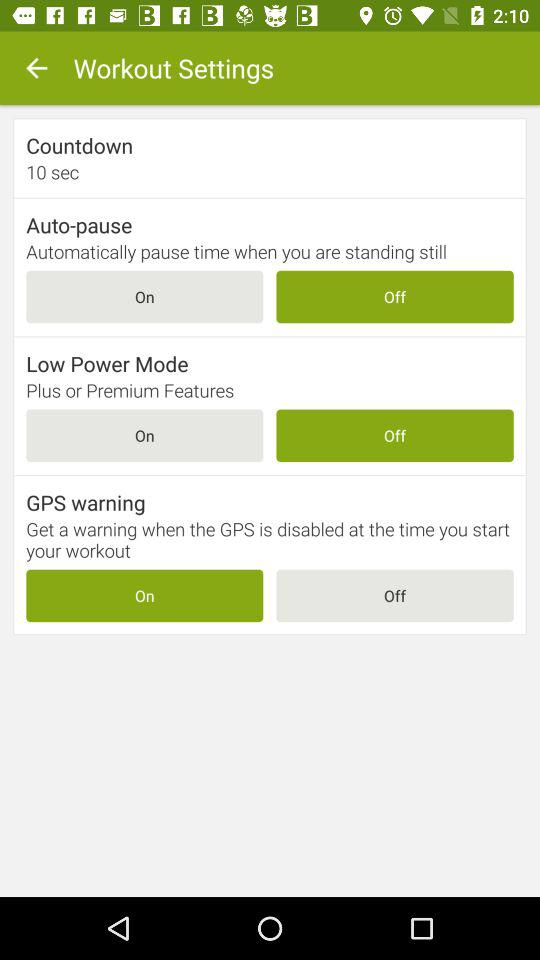What workout setting is in the ON state? The setting is "GPS warning". 